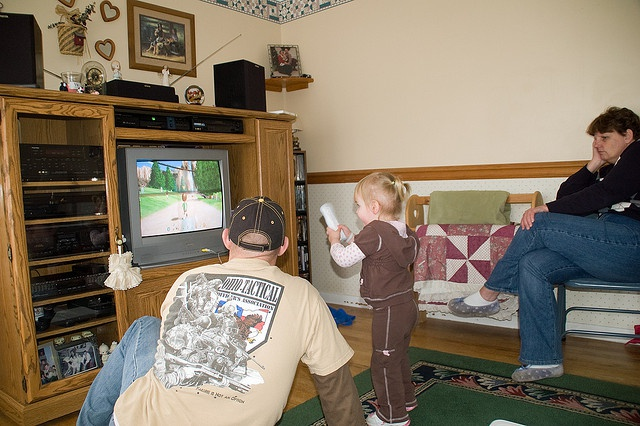Describe the objects in this image and their specific colors. I can see people in gray, tan, lightgray, and darkgray tones, people in gray, black, darkblue, and blue tones, tv in gray, lightgray, black, and darkgray tones, people in gray, maroon, brown, and tan tones, and couch in gray, brown, olive, and darkgray tones in this image. 